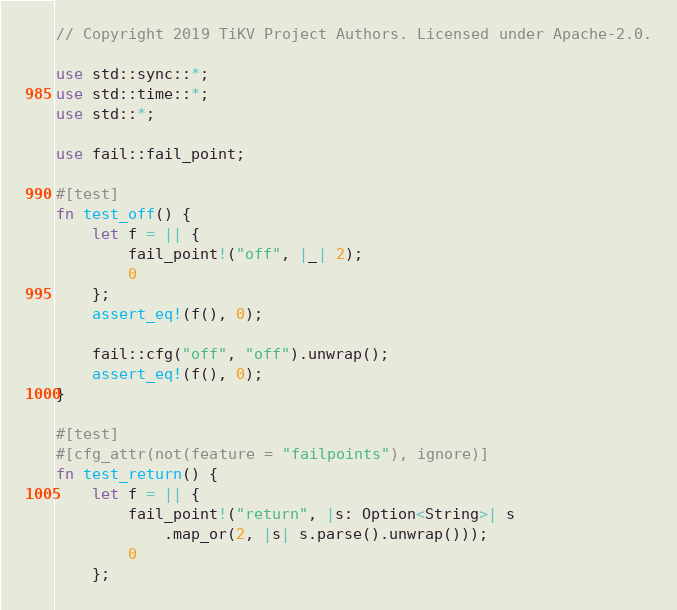<code> <loc_0><loc_0><loc_500><loc_500><_Rust_>// Copyright 2019 TiKV Project Authors. Licensed under Apache-2.0.

use std::sync::*;
use std::time::*;
use std::*;

use fail::fail_point;

#[test]
fn test_off() {
    let f = || {
        fail_point!("off", |_| 2);
        0
    };
    assert_eq!(f(), 0);

    fail::cfg("off", "off").unwrap();
    assert_eq!(f(), 0);
}

#[test]
#[cfg_attr(not(feature = "failpoints"), ignore)]
fn test_return() {
    let f = || {
        fail_point!("return", |s: Option<String>| s
            .map_or(2, |s| s.parse().unwrap()));
        0
    };</code> 